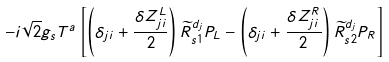<formula> <loc_0><loc_0><loc_500><loc_500>- i \sqrt { 2 } g _ { s } T ^ { a } \left [ \left ( \delta _ { j i } + \frac { \delta Z ^ { L } _ { j i } } { 2 } \right ) \widetilde { R } ^ { d _ { j } } _ { s 1 } P _ { L } - \left ( \delta _ { j i } + \frac { \delta Z ^ { R } _ { j i } } { 2 } \right ) \widetilde { R } ^ { d _ { j } } _ { s 2 } P _ { R } \right ]</formula> 